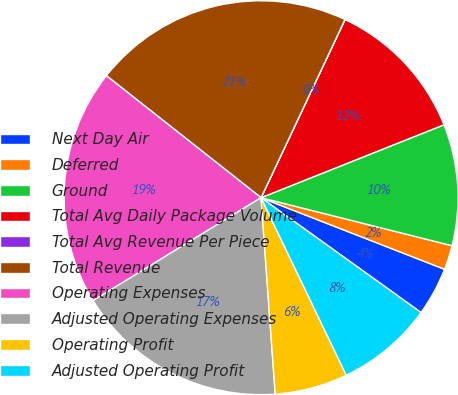Convert chart. <chart><loc_0><loc_0><loc_500><loc_500><pie_chart><fcel>Next Day Air<fcel>Deferred<fcel>Ground<fcel>Total Avg Daily Package Volume<fcel>Total Avg Revenue Per Piece<fcel>Total Revenue<fcel>Operating Expenses<fcel>Adjusted Operating Expenses<fcel>Operating Profit<fcel>Adjusted Operating Profit<nl><fcel>3.99%<fcel>2.0%<fcel>9.96%<fcel>11.95%<fcel>0.01%<fcel>21.38%<fcel>19.39%<fcel>17.4%<fcel>5.98%<fcel>7.97%<nl></chart> 